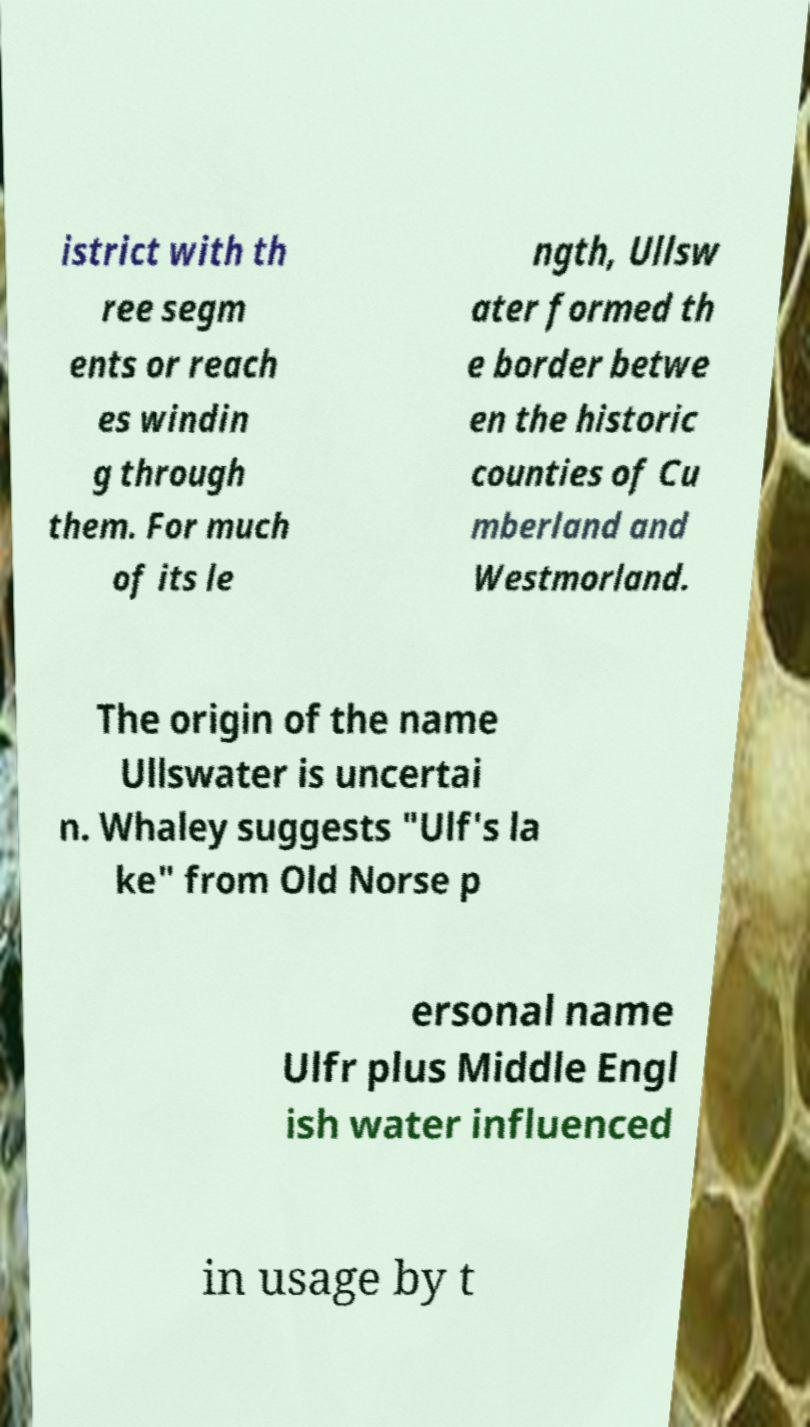What messages or text are displayed in this image? I need them in a readable, typed format. istrict with th ree segm ents or reach es windin g through them. For much of its le ngth, Ullsw ater formed th e border betwe en the historic counties of Cu mberland and Westmorland. The origin of the name Ullswater is uncertai n. Whaley suggests "Ulf's la ke" from Old Norse p ersonal name Ulfr plus Middle Engl ish water influenced in usage by t 